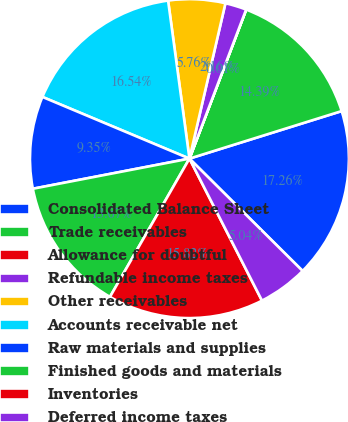Convert chart to OTSL. <chart><loc_0><loc_0><loc_500><loc_500><pie_chart><fcel>Consolidated Balance Sheet<fcel>Trade receivables<fcel>Allowance for doubtful<fcel>Refundable income taxes<fcel>Other receivables<fcel>Accounts receivable net<fcel>Raw materials and supplies<fcel>Finished goods and materials<fcel>Inventories<fcel>Deferred income taxes<nl><fcel>17.26%<fcel>14.39%<fcel>0.01%<fcel>2.16%<fcel>5.76%<fcel>16.54%<fcel>9.35%<fcel>13.67%<fcel>15.82%<fcel>5.04%<nl></chart> 